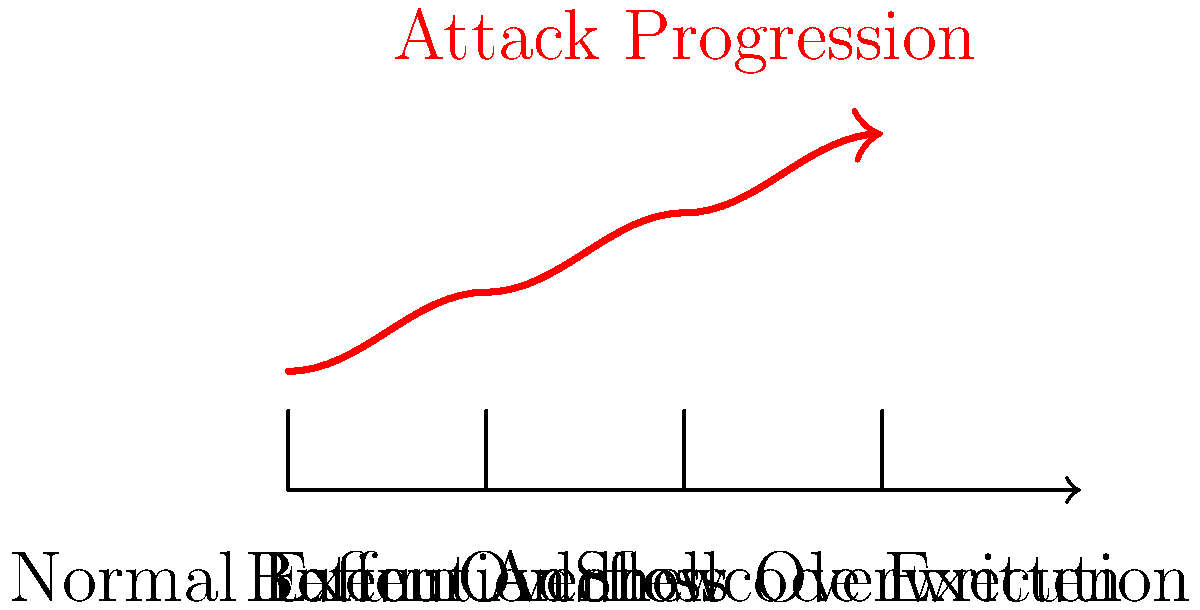In the vector graphic representation of a basic buffer overflow attack, which stage immediately precedes the execution of malicious shellcode? To understand the stages of a basic buffer overflow attack and identify the stage immediately preceding shellcode execution, let's analyze the graphic step-by-step:

1. The timeline shows four distinct stages of a buffer overflow attack:
   a) Normal Execution
   b) Buffer Overflow
   c) Return Address Overwritten
   d) Shellcode Execution

2. The red arrow indicates the progression of the attack, moving from left to right through each stage.

3. The stages are sequential, representing the order in which events occur during a buffer overflow attack:
   - Normal Execution: The program runs as intended.
   - Buffer Overflow: Input exceeds the allocated buffer size.
   - Return Address Overwritten: The excess input overwrites the return address on the stack.
   - Shellcode Execution: The malicious code (shellcode) is executed.

4. To determine which stage immediately precedes shellcode execution, we need to identify the stage just before the final one.

5. Observing the graphic, we can see that "Return Address Overwritten" is the stage immediately before "Shellcode Execution".

6. This makes sense in the context of a buffer overflow attack because:
   - Overwriting the return address is crucial for redirecting program flow.
   - Once the return address is overwritten, the next step is typically to execute the injected shellcode.

Therefore, the stage that immediately precedes the execution of malicious shellcode is "Return Address Overwritten".
Answer: Return Address Overwritten 